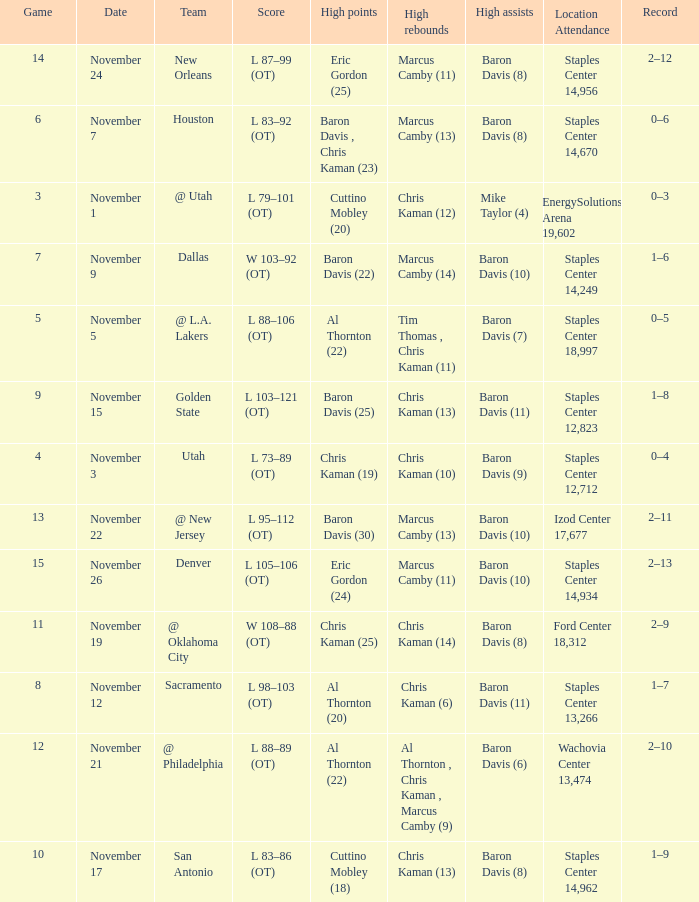Name the high assists for  l 98–103 (ot) Baron Davis (11). 